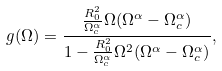<formula> <loc_0><loc_0><loc_500><loc_500>g ( \Omega ) = \frac { \frac { R _ { 0 } ^ { 2 } } { \Omega _ { c } ^ { \alpha } } \Omega ( \Omega ^ { \alpha } - \Omega _ { c } ^ { \alpha } ) } { 1 - \frac { R _ { 0 } ^ { 2 } } { \Omega _ { c } ^ { \alpha } } \Omega ^ { 2 } ( \Omega ^ { \alpha } - \Omega _ { c } ^ { \alpha } ) } ,</formula> 